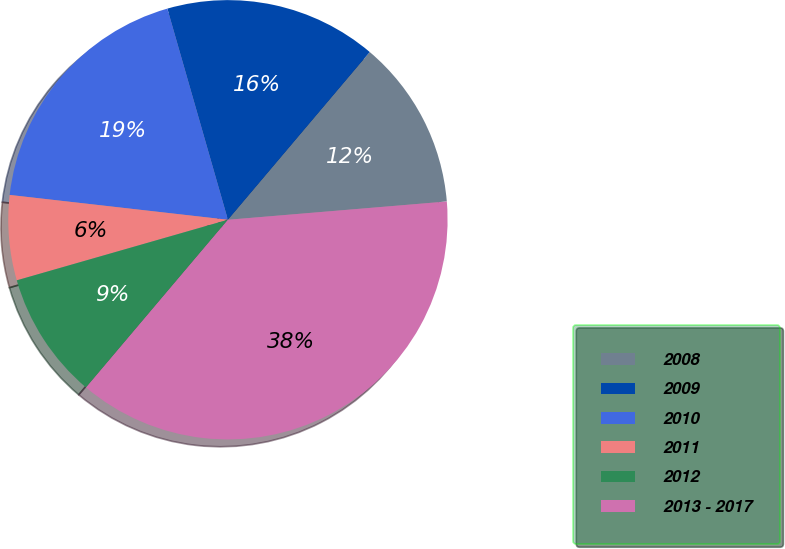Convert chart. <chart><loc_0><loc_0><loc_500><loc_500><pie_chart><fcel>2008<fcel>2009<fcel>2010<fcel>2011<fcel>2012<fcel>2013 - 2017<nl><fcel>12.5%<fcel>15.62%<fcel>18.75%<fcel>6.25%<fcel>9.38%<fcel>37.5%<nl></chart> 